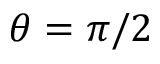Convert formula to latex. <formula><loc_0><loc_0><loc_500><loc_500>\theta = \pi / 2</formula> 